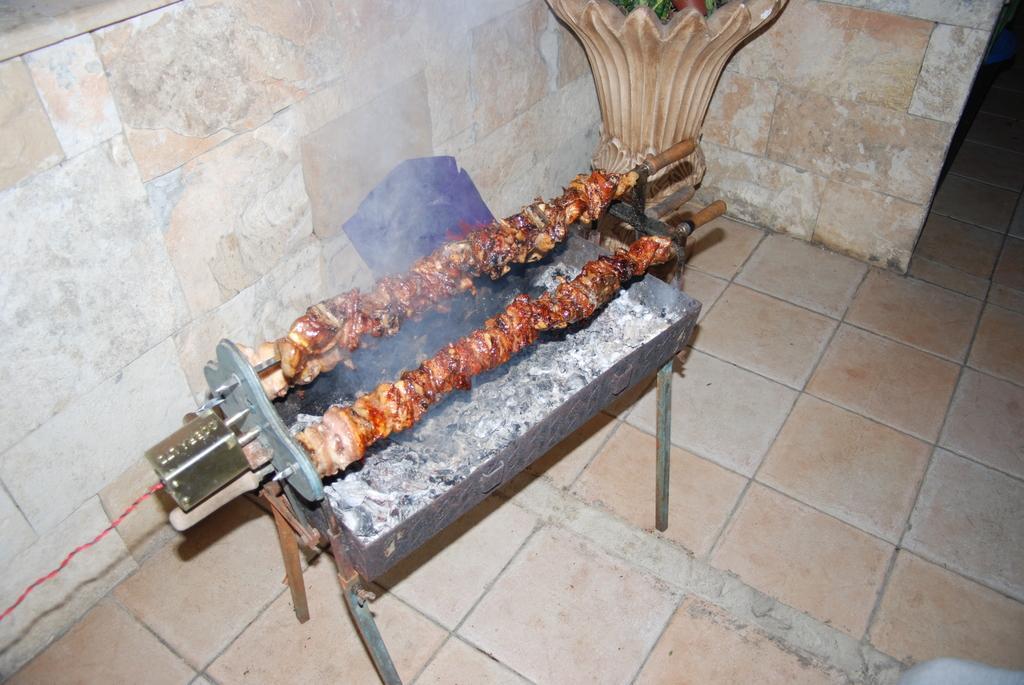In one or two sentences, can you explain what this image depicts? Here I can see few barbecues are placed on a metal object which seems to be a stove. It is in the shape of a table and it is placed on the floor. In this, I can see few fire coals. On the left side there is a connector attached to it. To this connector there is a cable. At the top of the image there is a wall. Beside the wall there is an object which seems to be a flower vase. 